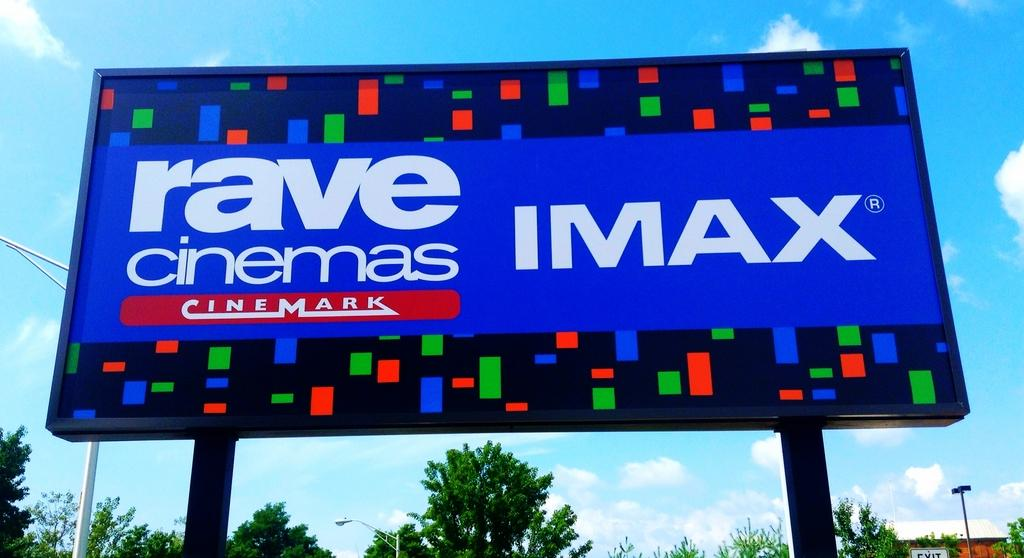Provide a one-sentence caption for the provided image. A large sign advertises IMAX theaters at Rave Cinemas. 